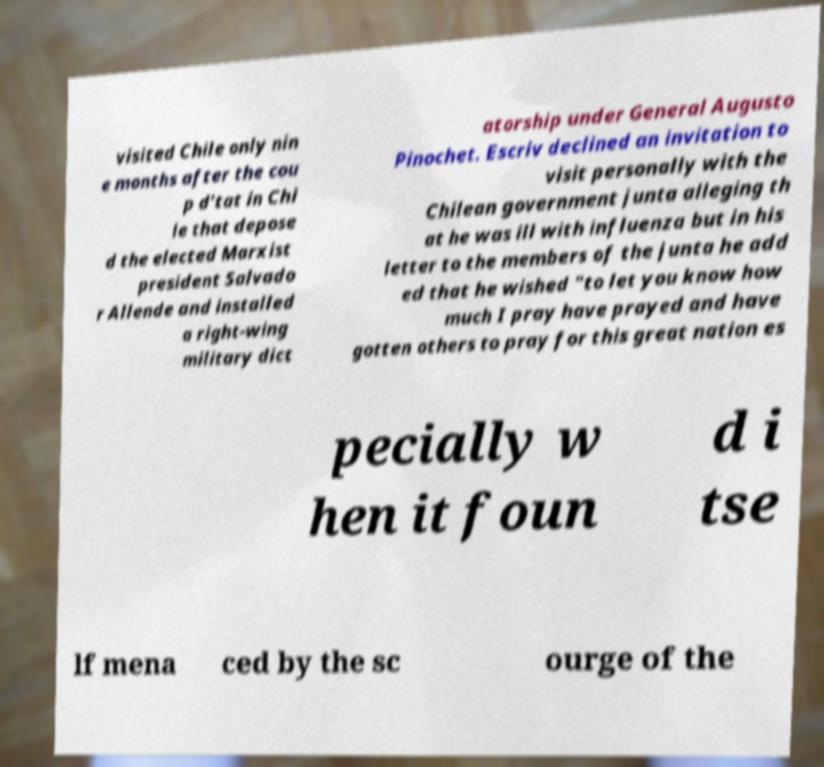I need the written content from this picture converted into text. Can you do that? visited Chile only nin e months after the cou p d'tat in Chi le that depose d the elected Marxist president Salvado r Allende and installed a right-wing military dict atorship under General Augusto Pinochet. Escriv declined an invitation to visit personally with the Chilean government junta alleging th at he was ill with influenza but in his letter to the members of the junta he add ed that he wished "to let you know how much I pray have prayed and have gotten others to pray for this great nation es pecially w hen it foun d i tse lf mena ced by the sc ourge of the 